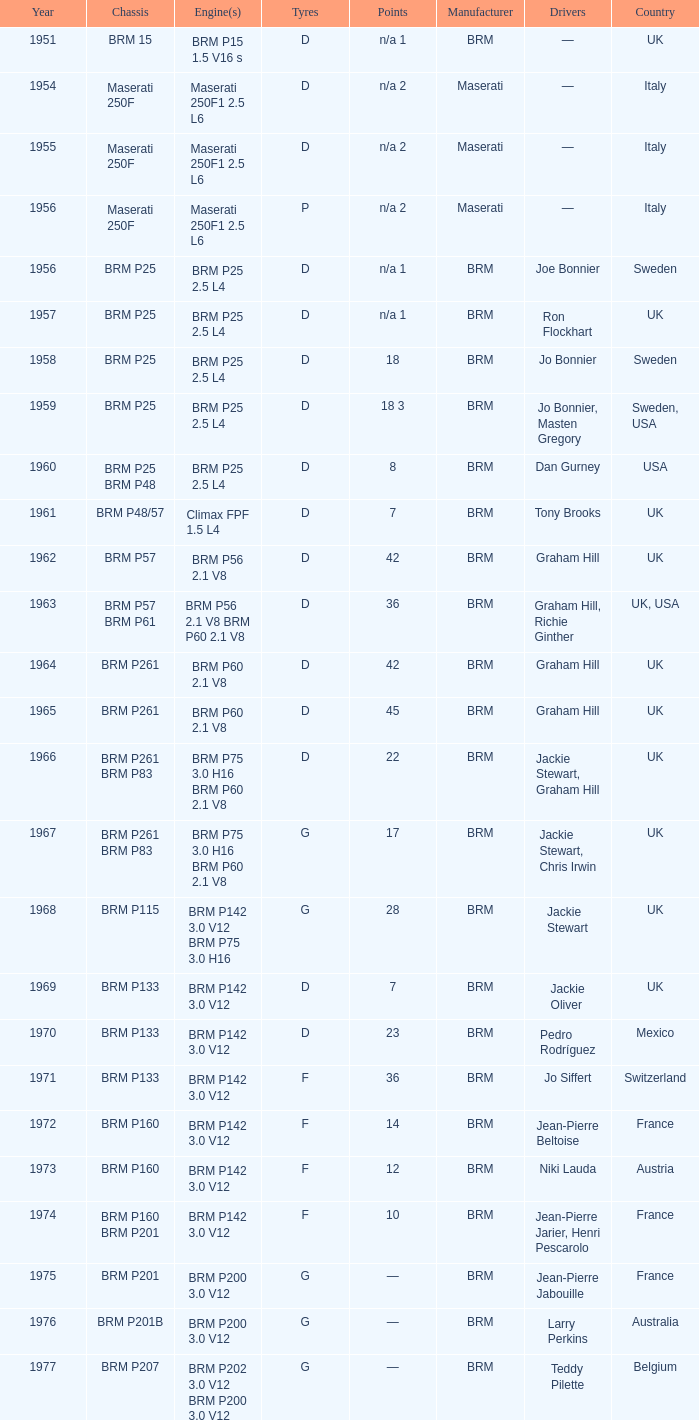Specify the 1961 vehicle structure BRM P48/57. 